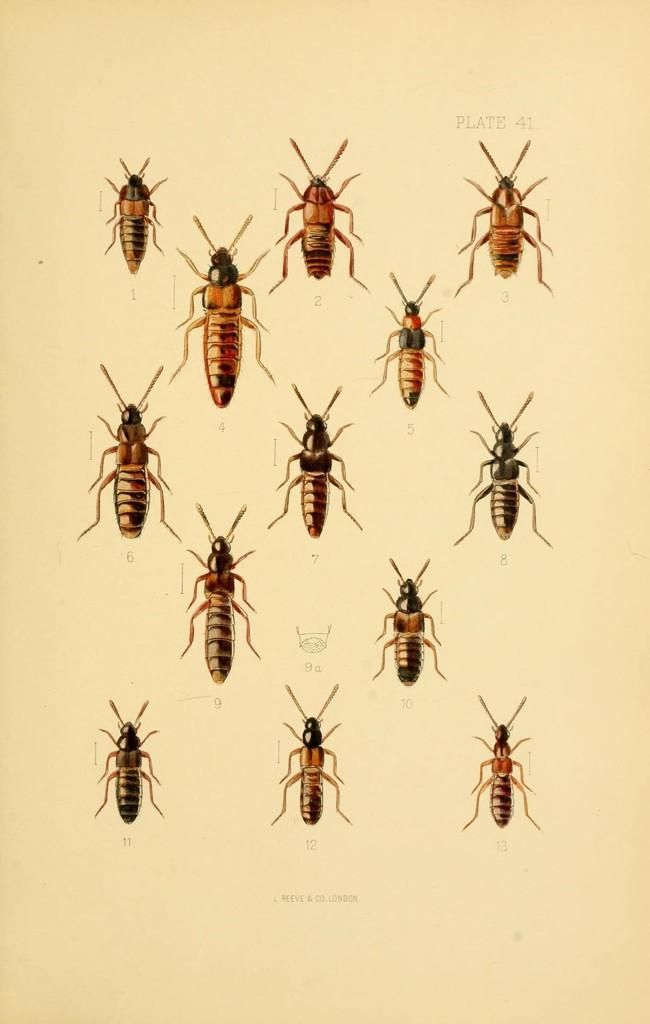What is the main subject of the art in the image? The main subject of the art in the image is insects. What is the color of the paper on which the art is drawn? The art is on a cream-colored paper. Is there any text or writing on the paper? Yes, there is writing on the paper. How does the basin contribute to the wealth of the insects in the image? There is no basin present in the image, and therefore it cannot contribute to the wealth of the insects. What type of shame is depicted in the image? There is no shame depicted in the image; it features an art of insects on a cream-colored paper with writing. 